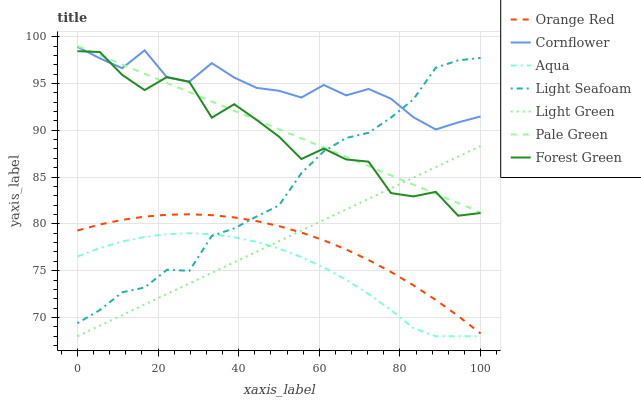Does Aqua have the minimum area under the curve?
Answer yes or no. Yes. Does Cornflower have the maximum area under the curve?
Answer yes or no. Yes. Does Forest Green have the minimum area under the curve?
Answer yes or no. No. Does Forest Green have the maximum area under the curve?
Answer yes or no. No. Is Pale Green the smoothest?
Answer yes or no. Yes. Is Forest Green the roughest?
Answer yes or no. Yes. Is Aqua the smoothest?
Answer yes or no. No. Is Aqua the roughest?
Answer yes or no. No. Does Aqua have the lowest value?
Answer yes or no. Yes. Does Forest Green have the lowest value?
Answer yes or no. No. Does Pale Green have the highest value?
Answer yes or no. Yes. Does Forest Green have the highest value?
Answer yes or no. No. Is Orange Red less than Pale Green?
Answer yes or no. Yes. Is Pale Green greater than Orange Red?
Answer yes or no. Yes. Does Orange Red intersect Light Seafoam?
Answer yes or no. Yes. Is Orange Red less than Light Seafoam?
Answer yes or no. No. Is Orange Red greater than Light Seafoam?
Answer yes or no. No. Does Orange Red intersect Pale Green?
Answer yes or no. No. 